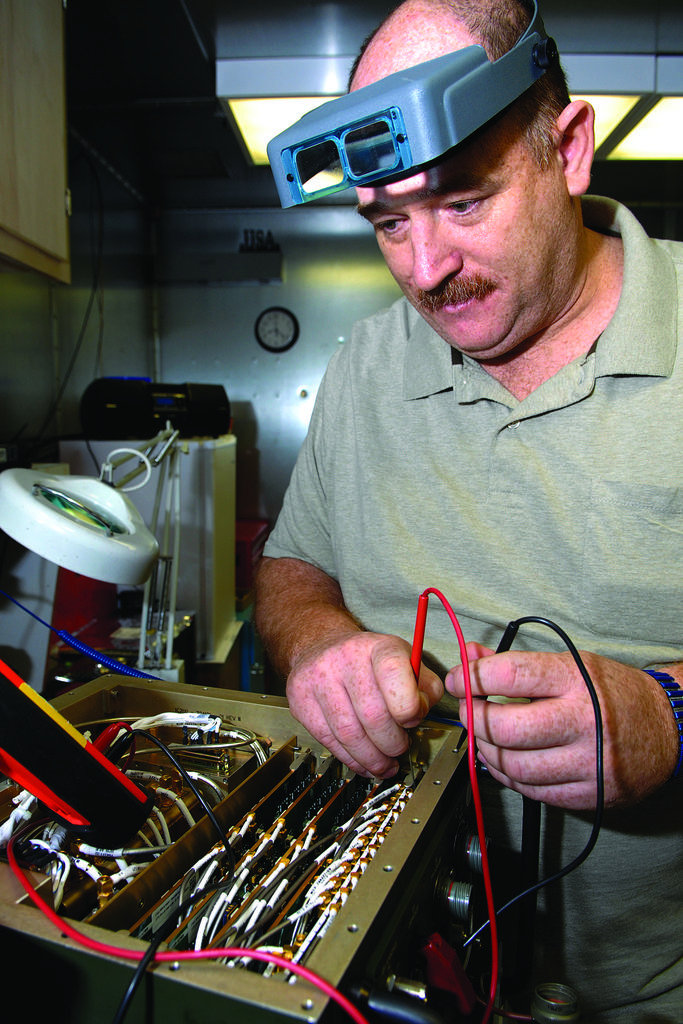What is the main subject of the image? The main subject of the image is a man. What is the man wearing in the image? The man is wearing a green shirt in the image. What can be seen in front of the man? There is a machine in front of the man in the image. What is the man doing in the image? The man is doing something in the image, but we cannot determine the specific action from the provided facts. What type of education does the man's elbow have in the image? There is no mention of the man's elbow or education in the image, so we cannot answer this question. 